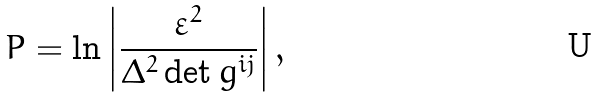<formula> <loc_0><loc_0><loc_500><loc_500>P = \ln \left | \frac { { \varepsilon } ^ { 2 } } { \Delta ^ { 2 } \det g ^ { i j } } \right | ,</formula> 